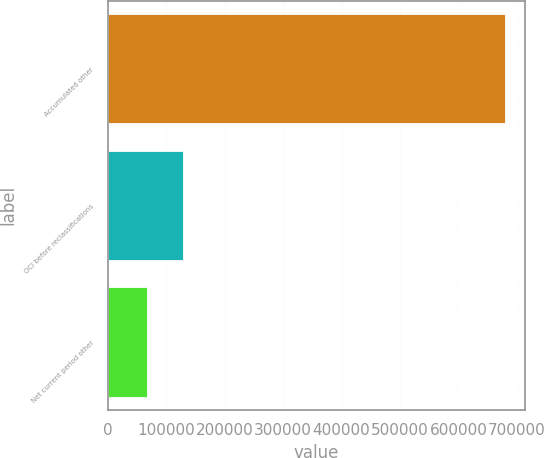Convert chart. <chart><loc_0><loc_0><loc_500><loc_500><bar_chart><fcel>Accumulated other<fcel>OCI before reclassifications<fcel>Net current period other<nl><fcel>680095<fcel>127999<fcel>66655<nl></chart> 